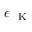Convert formula to latex. <formula><loc_0><loc_0><loc_500><loc_500>\epsilon _ { K }</formula> 